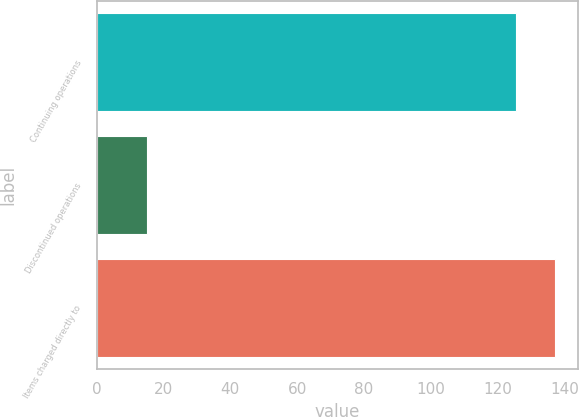Convert chart to OTSL. <chart><loc_0><loc_0><loc_500><loc_500><bar_chart><fcel>Continuing operations<fcel>Discontinued operations<fcel>Items charged directly to<nl><fcel>125.4<fcel>15<fcel>137.17<nl></chart> 